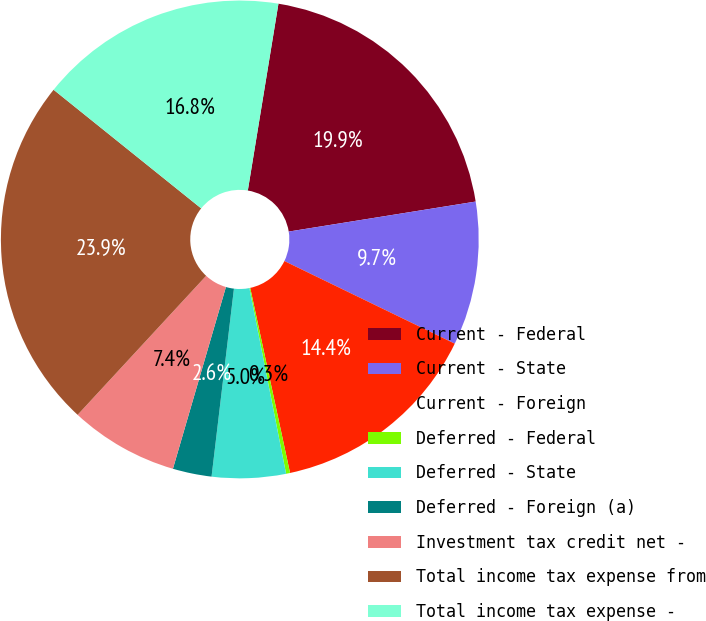<chart> <loc_0><loc_0><loc_500><loc_500><pie_chart><fcel>Current - Federal<fcel>Current - State<fcel>Current - Foreign<fcel>Deferred - Federal<fcel>Deferred - State<fcel>Deferred - Foreign (a)<fcel>Investment tax credit net -<fcel>Total income tax expense from<fcel>Total income tax expense -<nl><fcel>19.88%<fcel>9.72%<fcel>14.44%<fcel>0.27%<fcel>4.99%<fcel>2.63%<fcel>7.36%<fcel>23.9%<fcel>16.81%<nl></chart> 